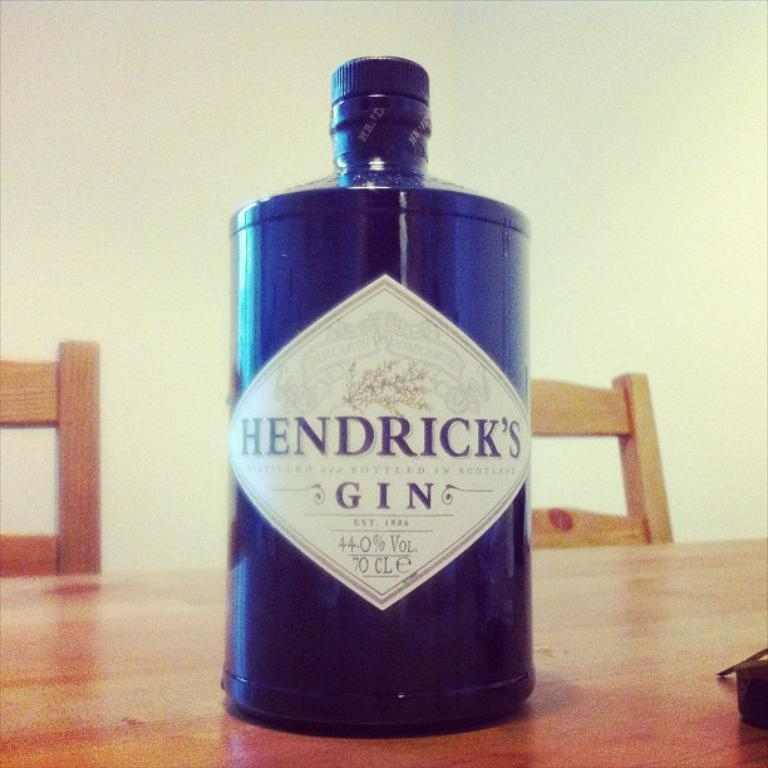What is on the bottle that is visible in the image? There is a label on the bottle in the image. What is the object on the table in the image? The object on the table in the image is not specified, but we know there is an object present. What type of furniture is in the image? There are chairs in the image. What is the background of the image? There is a wall in the image. What type of wristwatch is visible on the wall in the image? There is no wristwatch present in the image; it only mentions a wall. What country is depicted in the image? The image does not depict any country; it only contains a bottle, an object on a table, chairs, and a wall. 